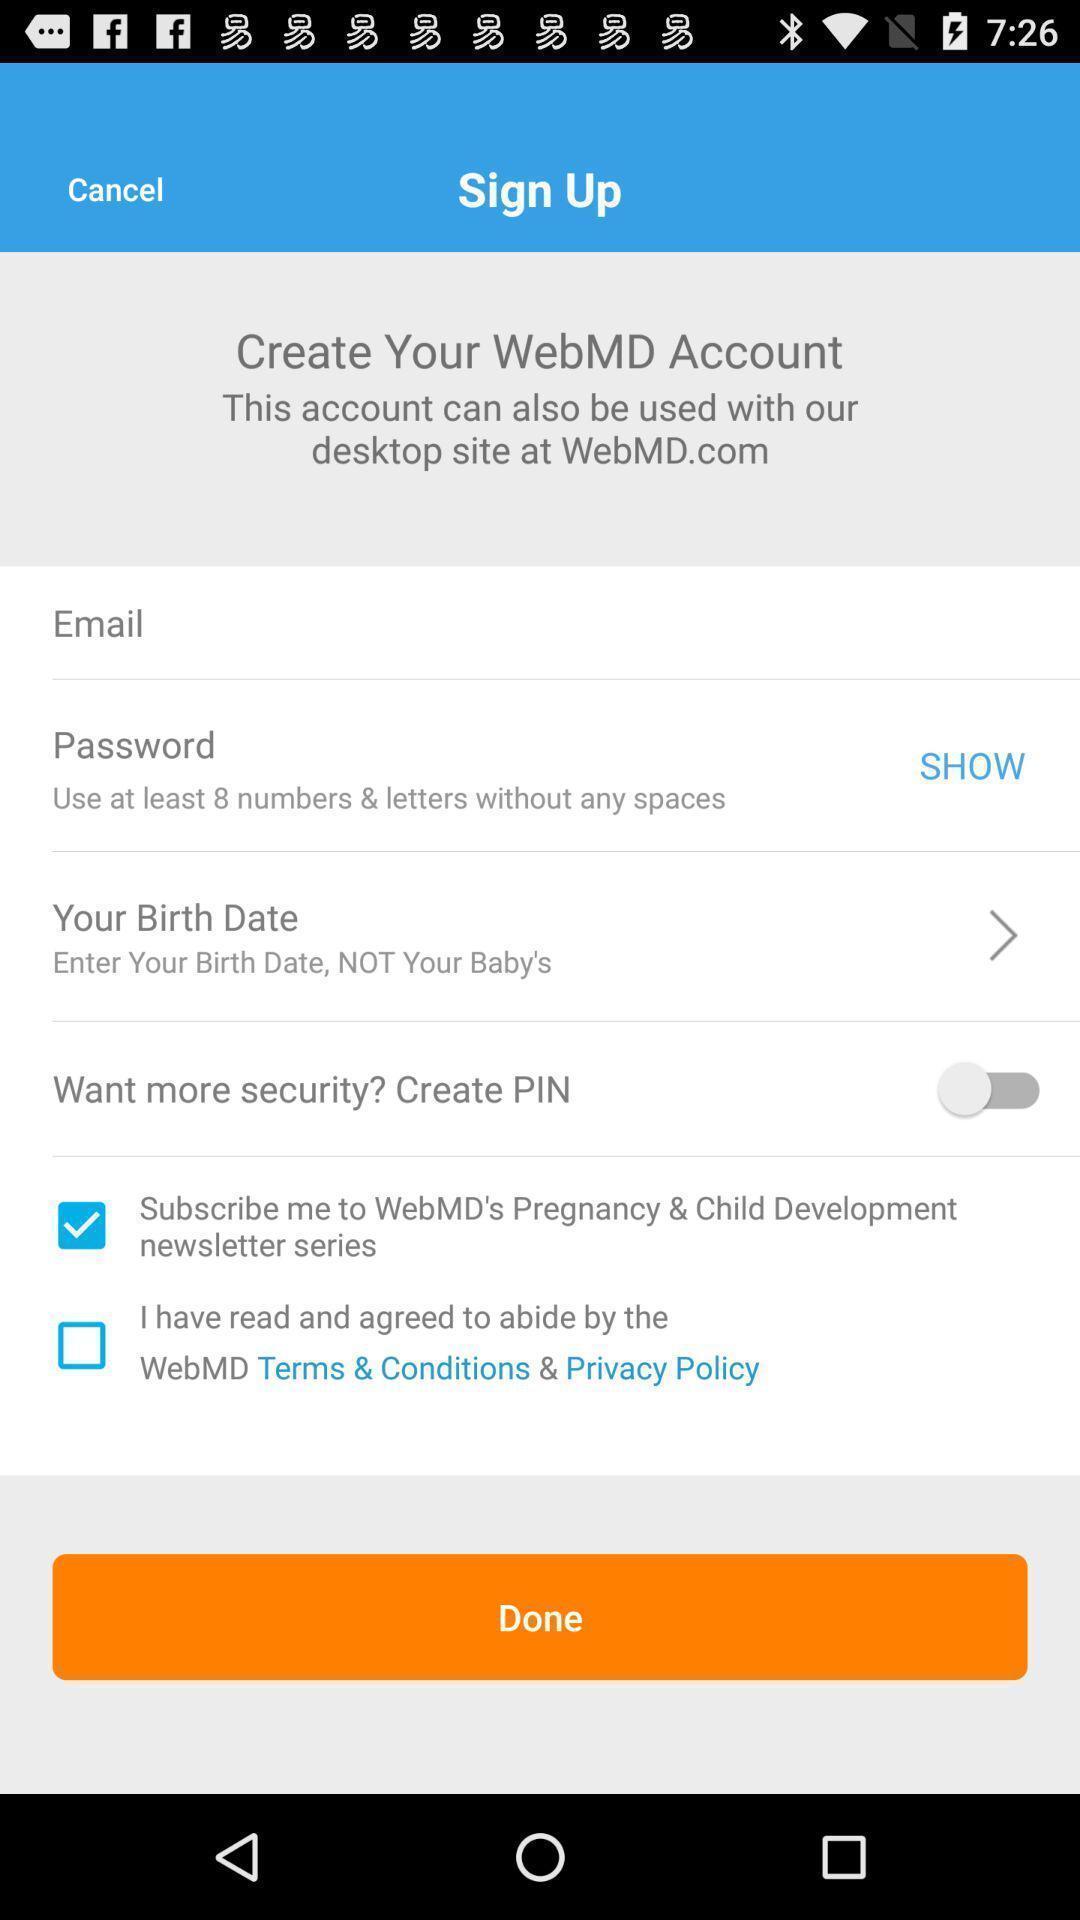Tell me what you see in this picture. Signup page with some options in application. 